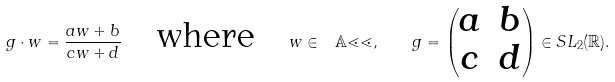Convert formula to latex. <formula><loc_0><loc_0><loc_500><loc_500>g \cdot w = \frac { a w + b } { c w + d } \quad \text {where} \quad w \in \mathbb { \ A l l , } \quad g = \begin{pmatrix} a & b \\ c & d \end{pmatrix} \in S L _ { 2 } ( \mathbb { R } ) .</formula> 